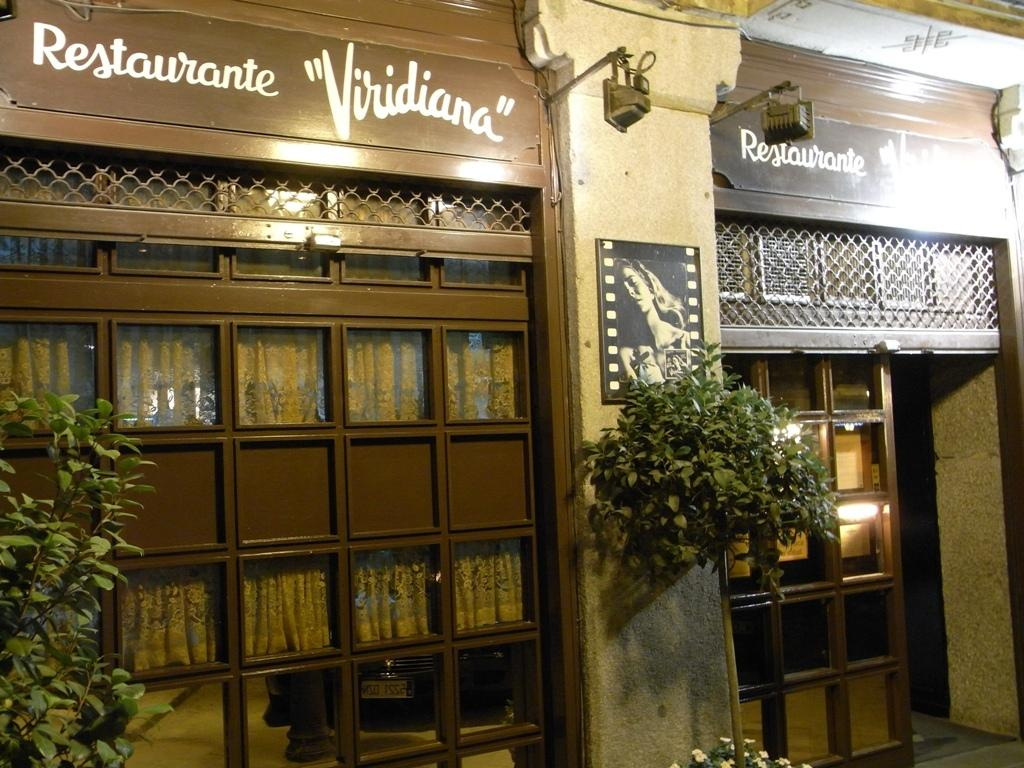<image>
Relay a brief, clear account of the picture shown. Store with a plant hanging on the wall and the words "Restaurante Viridiana" on top. 